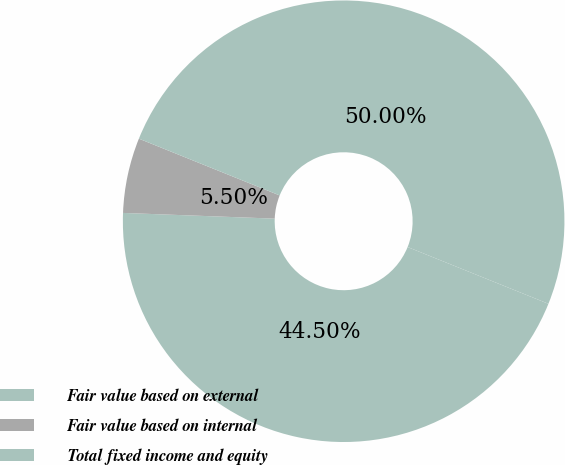Convert chart. <chart><loc_0><loc_0><loc_500><loc_500><pie_chart><fcel>Fair value based on external<fcel>Fair value based on internal<fcel>Total fixed income and equity<nl><fcel>44.5%<fcel>5.5%<fcel>50.0%<nl></chart> 